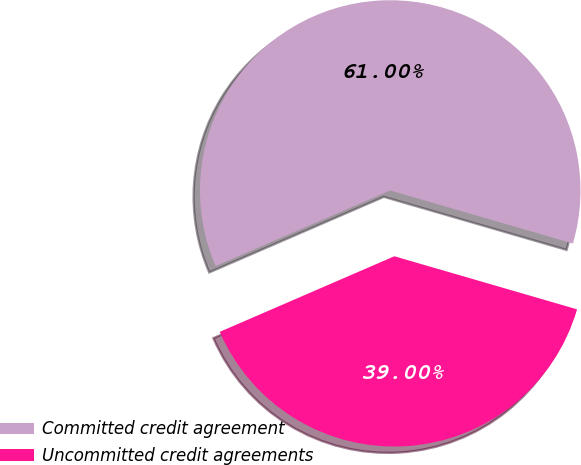Convert chart. <chart><loc_0><loc_0><loc_500><loc_500><pie_chart><fcel>Committed credit agreement<fcel>Uncommitted credit agreements<nl><fcel>61.0%<fcel>39.0%<nl></chart> 